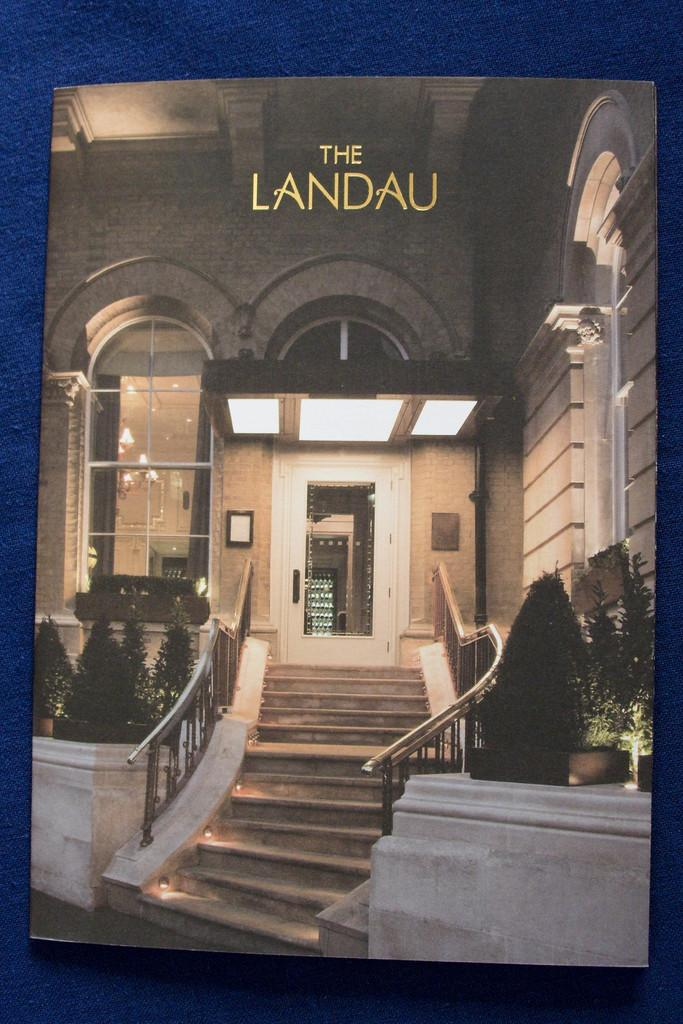<image>
Write a terse but informative summary of the picture. The exterior of the Landau hotel is seen. 